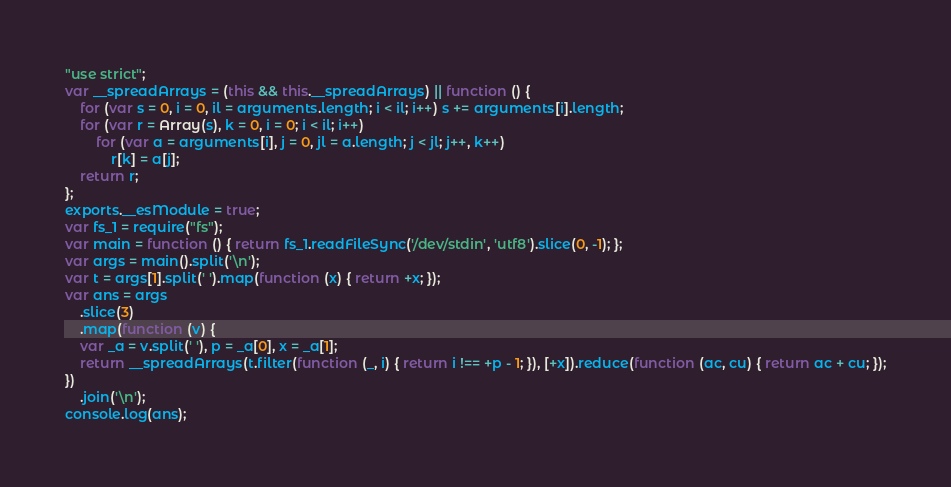Convert code to text. <code><loc_0><loc_0><loc_500><loc_500><_JavaScript_>"use strict";
var __spreadArrays = (this && this.__spreadArrays) || function () {
    for (var s = 0, i = 0, il = arguments.length; i < il; i++) s += arguments[i].length;
    for (var r = Array(s), k = 0, i = 0; i < il; i++)
        for (var a = arguments[i], j = 0, jl = a.length; j < jl; j++, k++)
            r[k] = a[j];
    return r;
};
exports.__esModule = true;
var fs_1 = require("fs");
var main = function () { return fs_1.readFileSync('/dev/stdin', 'utf8').slice(0, -1); };
var args = main().split('\n');
var t = args[1].split(' ').map(function (x) { return +x; });
var ans = args
    .slice(3)
    .map(function (v) {
    var _a = v.split(' '), p = _a[0], x = _a[1];
    return __spreadArrays(t.filter(function (_, i) { return i !== +p - 1; }), [+x]).reduce(function (ac, cu) { return ac + cu; });
})
    .join('\n');
console.log(ans);
</code> 